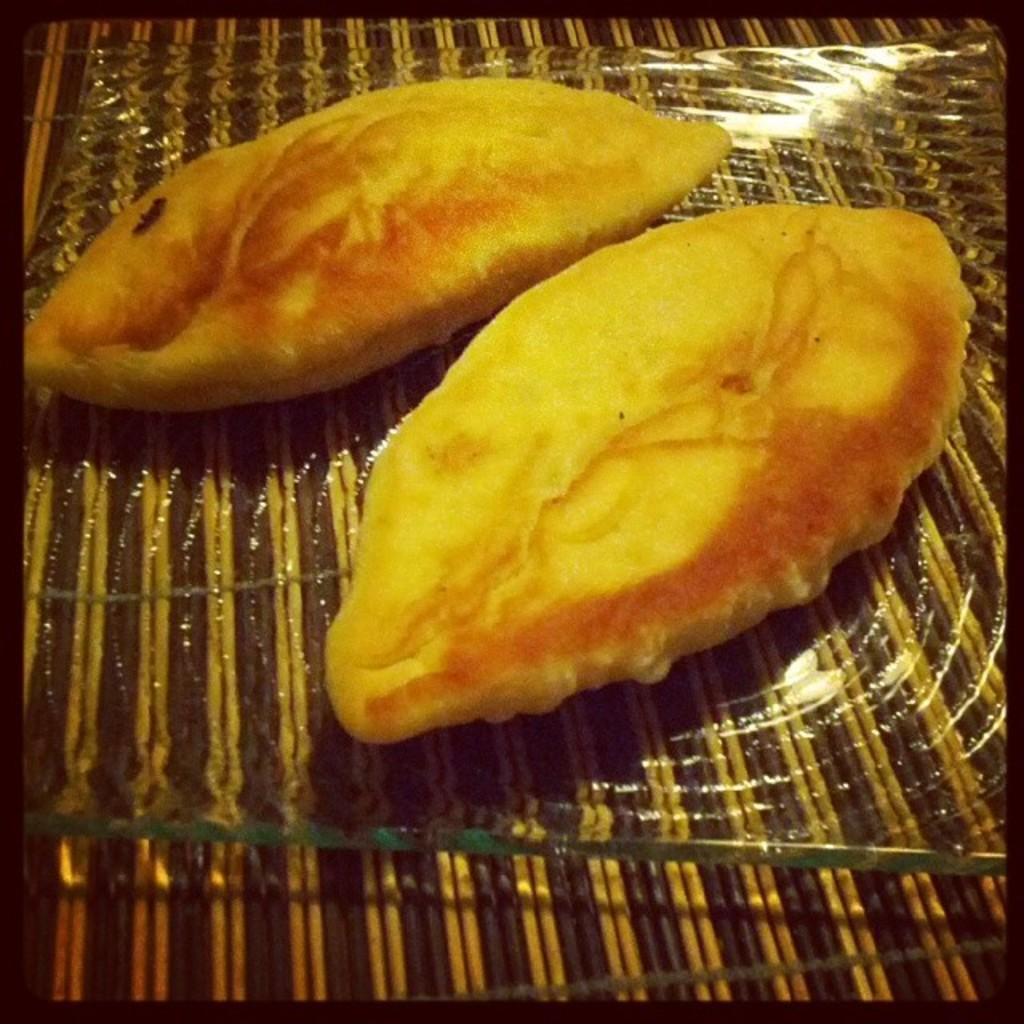What is present in the image that can be eaten? There are food items in the image that can be eaten. How are the food items arranged in the image? The food items are placed on a mat in the image. What feature surrounds the content of the image? The image has borders that surround its content. Can you see any streams of water in the image? There are no streams of water present in the image. What type of soap is used to clean the dolls in the image? There are no dolls or soap present in the image. 